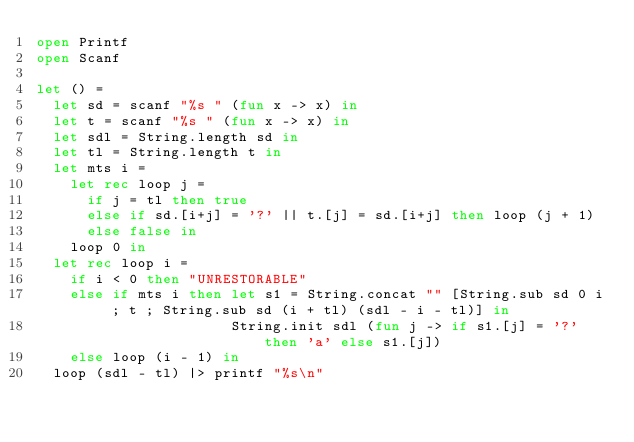<code> <loc_0><loc_0><loc_500><loc_500><_OCaml_>open Printf
open Scanf

let () =
  let sd = scanf "%s " (fun x -> x) in
  let t = scanf "%s " (fun x -> x) in
  let sdl = String.length sd in
  let tl = String.length t in
  let mts i =
    let rec loop j =
      if j = tl then true
      else if sd.[i+j] = '?' || t.[j] = sd.[i+j] then loop (j + 1)
      else false in
    loop 0 in
  let rec loop i =
    if i < 0 then "UNRESTORABLE"
    else if mts i then let s1 = String.concat "" [String.sub sd 0 i ; t ; String.sub sd (i + tl) (sdl - i - tl)] in
                       String.init sdl (fun j -> if s1.[j] = '?' then 'a' else s1.[j])
    else loop (i - 1) in
  loop (sdl - tl) |> printf "%s\n"
</code> 